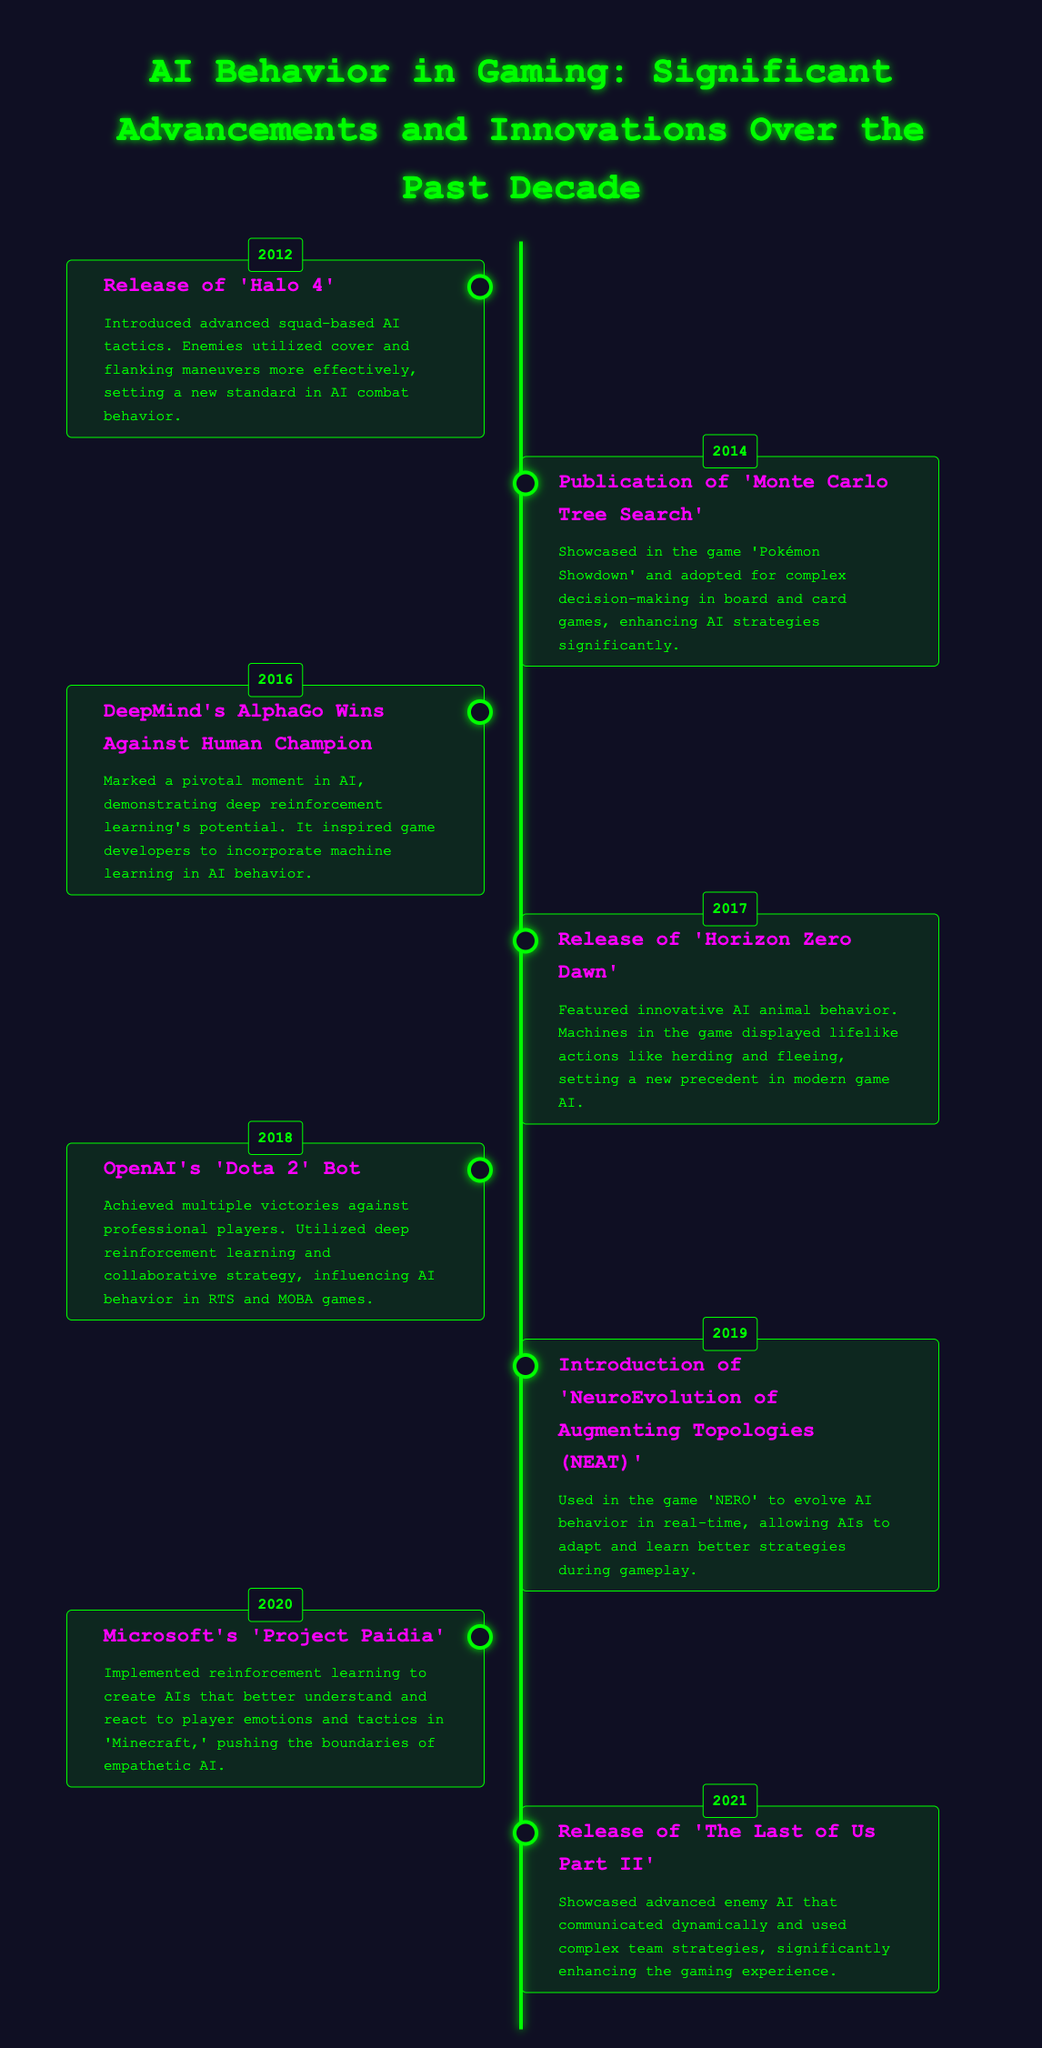What year did 'Halo 4' release? The release year of 'Halo 4' is listed in the timeline section of the document.
Answer: 2012 What significant AI tactic was introduced in 'Horizon Zero Dawn'? The document mentions innovative AI animal behavior in 'Horizon Zero Dawn'.
Answer: Lifelike actions Which AI bot achieved victories in 'Dota 2'? The document names the specific AI bot that succeeded against professional players in 'Dota 2'.
Answer: OpenAI's 'Dota 2' Bot What approach did DeepMind's AlphaGo use? The timeline specifies the method used by DeepMind's AlphaGo to win against a human champion.
Answer: Deep reinforcement learning In what year was 'The Last of Us Part II' released? The release date of 'The Last of Us Part II' can be found in the timeline.
Answer: 2021 What was featured in 'Minecraft' according to Microsoft's 'Project Paidia'? The document describes the focus of 'Project Paidia' implemented in 'Minecraft'.
Answer: Empathetic AI How did 'NERO' utilize NEAT? The timeline mentions how 'NERO' used NEAT in terms of AI behavior.
Answer: Evolve AI behavior What is the purpose of the Monte Carlo Tree Search? The document highlights the application of Monte Carlo Tree Search in AI strategies.
Answer: Complex decision-making What advanced feature did enemies in 'The Last of Us Part II' use? The timeline states that the enemy AI in 'The Last of Us Part II' communicated.
Answer: Dynamic communication 